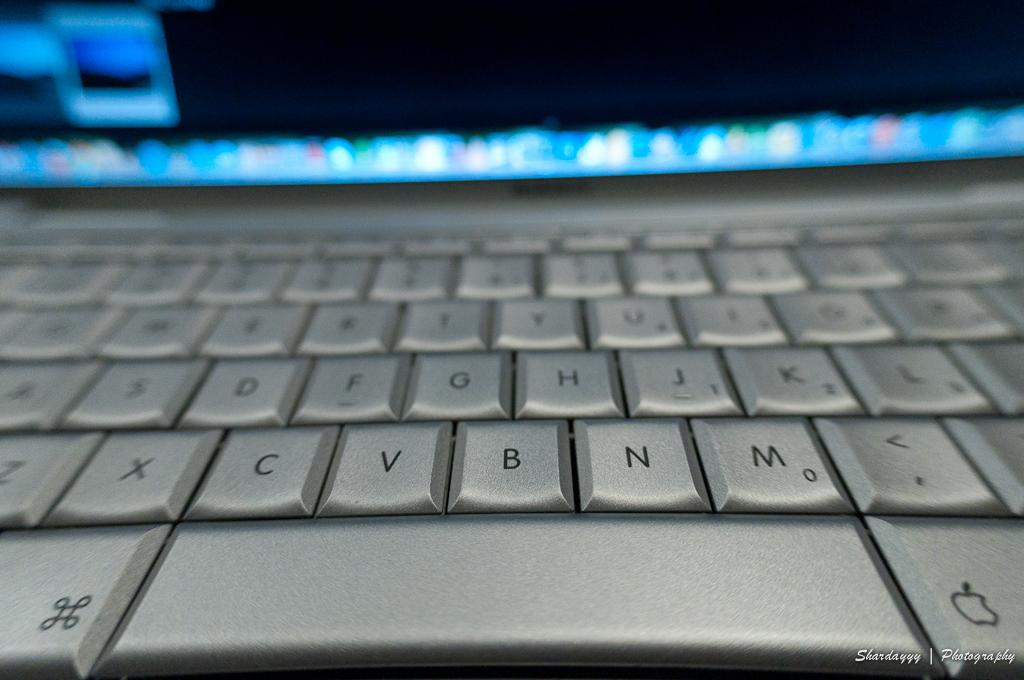<image>
Write a terse but informative summary of the picture. a close up of a silver key board with keys like B, N, and M 